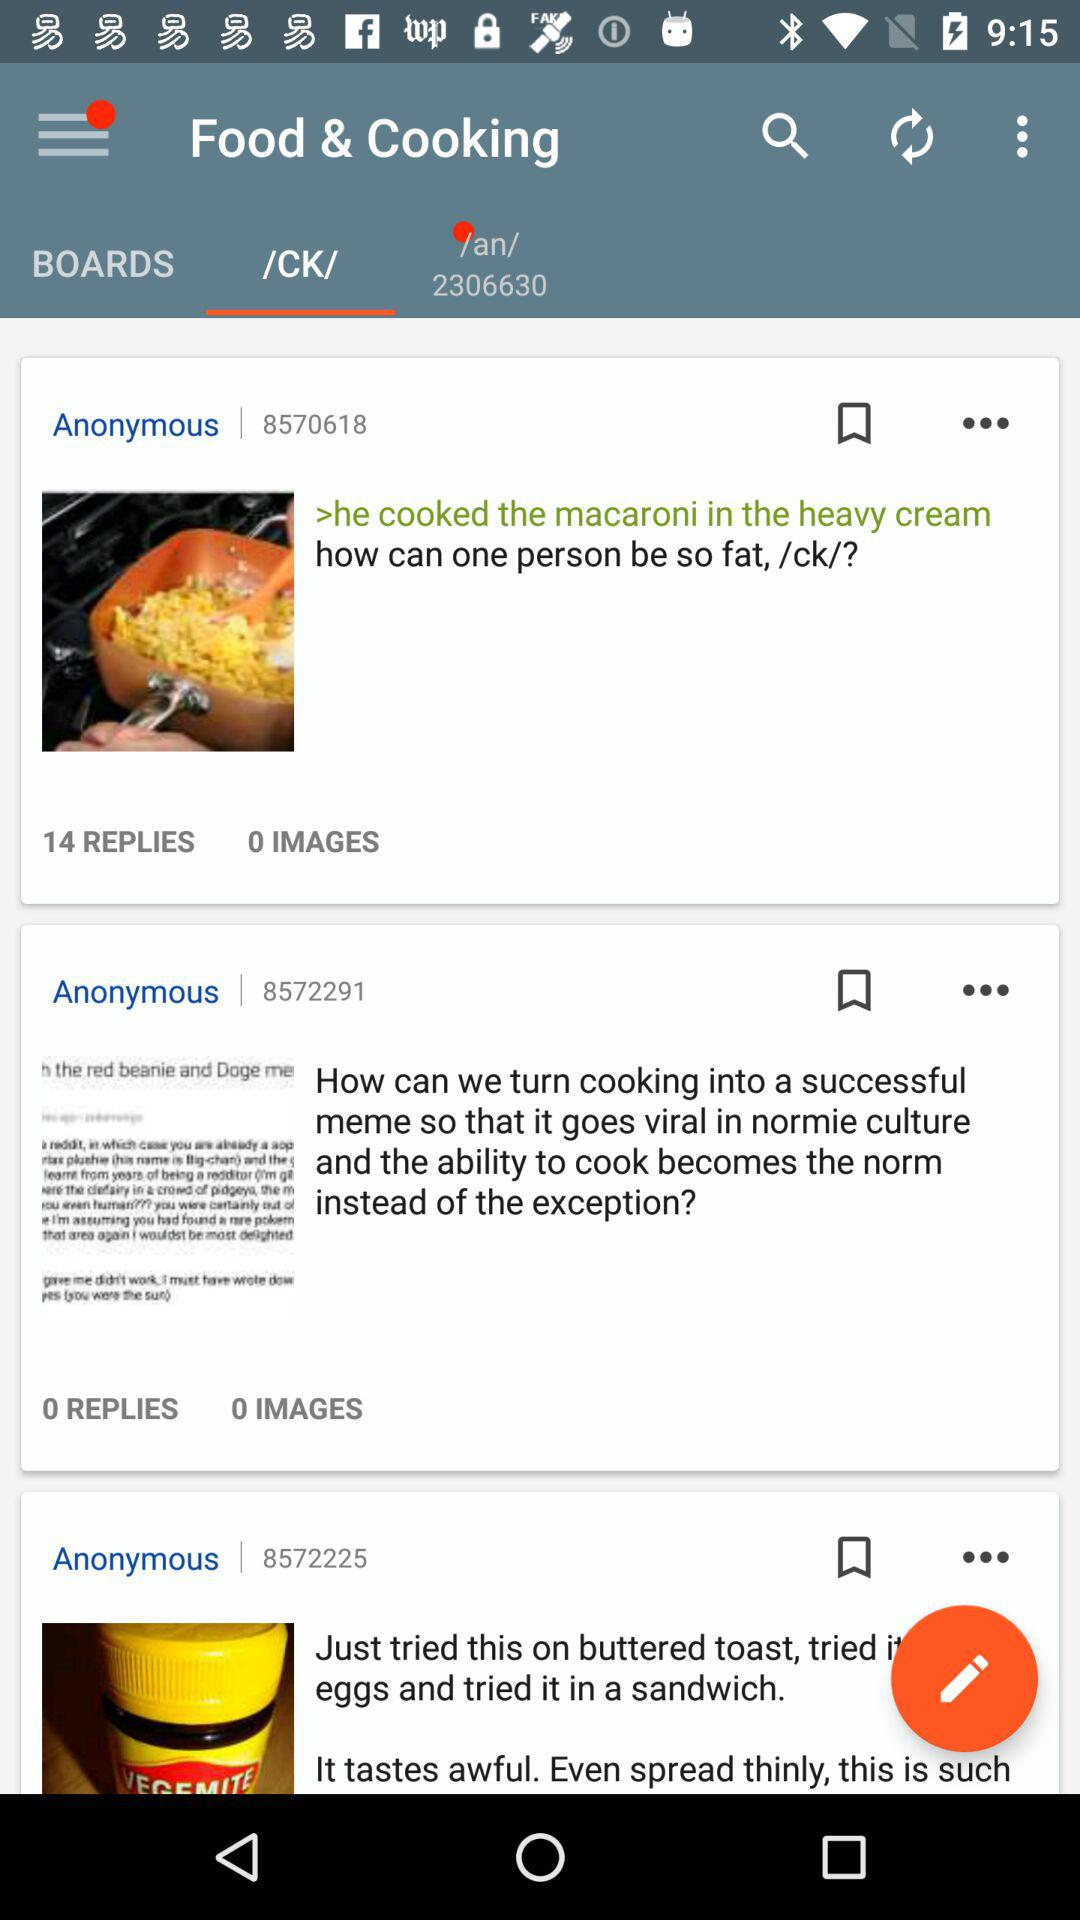Which tab is selected? The selected tab is "/CK/". 